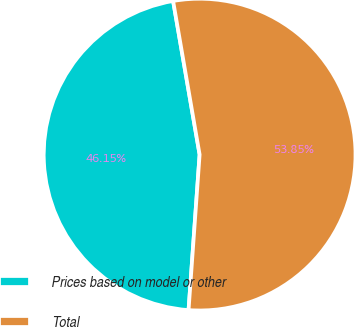Convert chart. <chart><loc_0><loc_0><loc_500><loc_500><pie_chart><fcel>Prices based on model or other<fcel>Total<nl><fcel>46.15%<fcel>53.85%<nl></chart> 